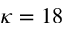Convert formula to latex. <formula><loc_0><loc_0><loc_500><loc_500>\kappa = 1 8</formula> 